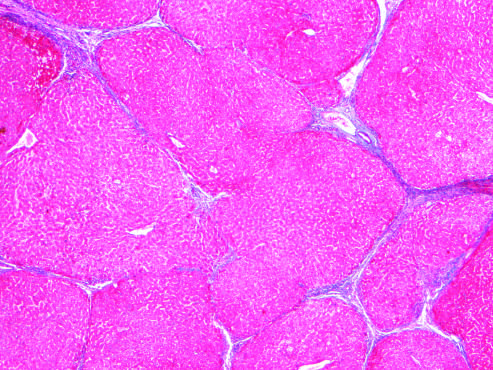when are most scars gone?
Answer the question using a single word or phrase. After 1 year of abstinance 